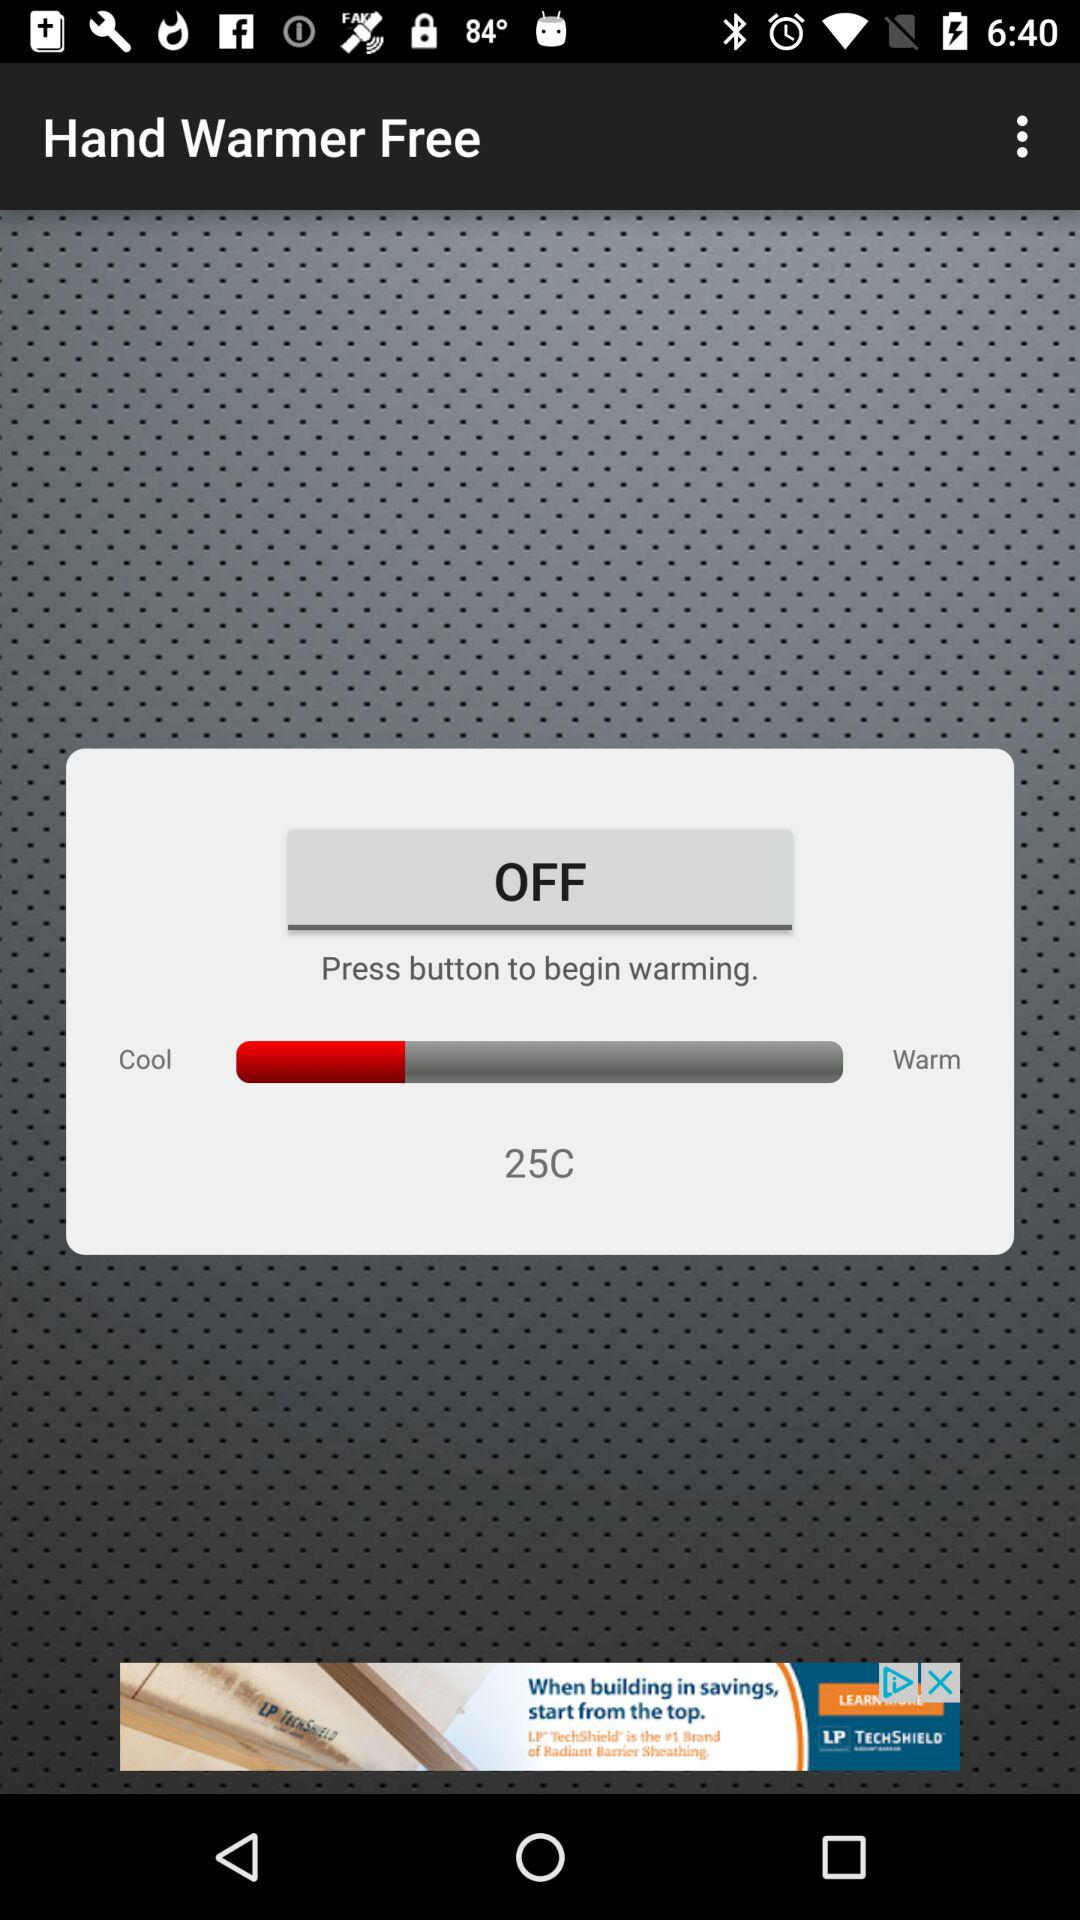What is the temperature? The temperature is 25 °C. 